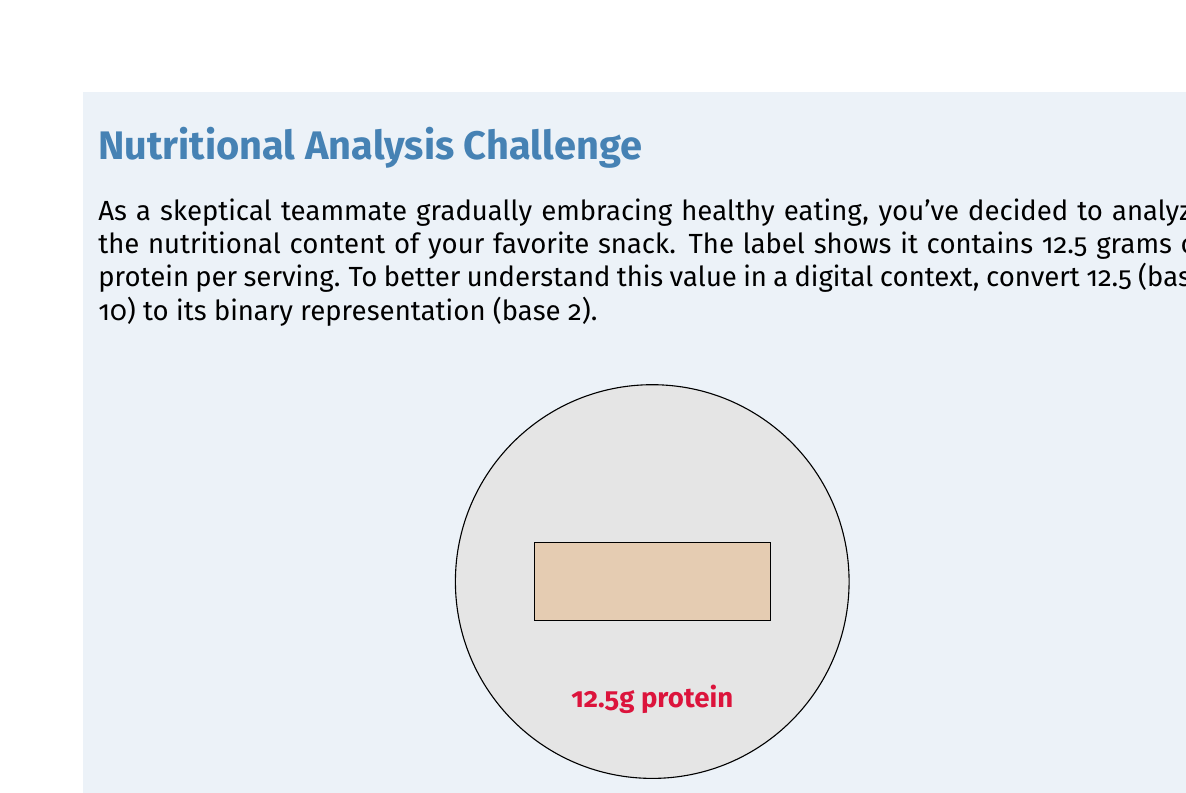Give your solution to this math problem. To convert 12.5 (base 10) to binary (base 2), we need to separate the integer and fractional parts:

1. Integer part: 12
2. Fractional part: 0.5

For the integer part (12):
$$12 \div 2 = 6 \text{ remainder } 0$$
$$6 \div 2 = 3 \text{ remainder } 0$$
$$3 \div 2 = 1 \text{ remainder } 1$$
$$1 \div 2 = 0 \text{ remainder } 1$$

Reading the remainders from bottom to top, we get: 1100

For the fractional part (0.5):
$$0.5 \times 2 = 1.0$$

The fractional part becomes: 1

Combining the results:

$$12.5_{10} = 1100.1_2$$
Answer: $1100.1_2$ 